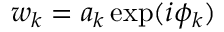<formula> <loc_0><loc_0><loc_500><loc_500>w _ { k } = a _ { k } \exp ( i \phi _ { k } )</formula> 